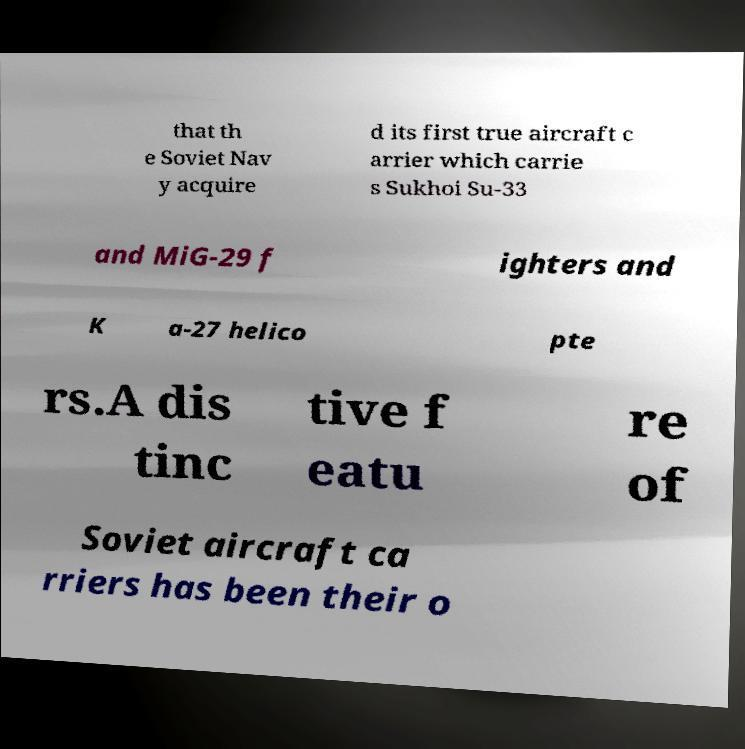Please read and relay the text visible in this image. What does it say? that th e Soviet Nav y acquire d its first true aircraft c arrier which carrie s Sukhoi Su-33 and MiG-29 f ighters and K a-27 helico pte rs.A dis tinc tive f eatu re of Soviet aircraft ca rriers has been their o 